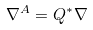Convert formula to latex. <formula><loc_0><loc_0><loc_500><loc_500>\nabla ^ { A } = Q ^ { * } \nabla</formula> 